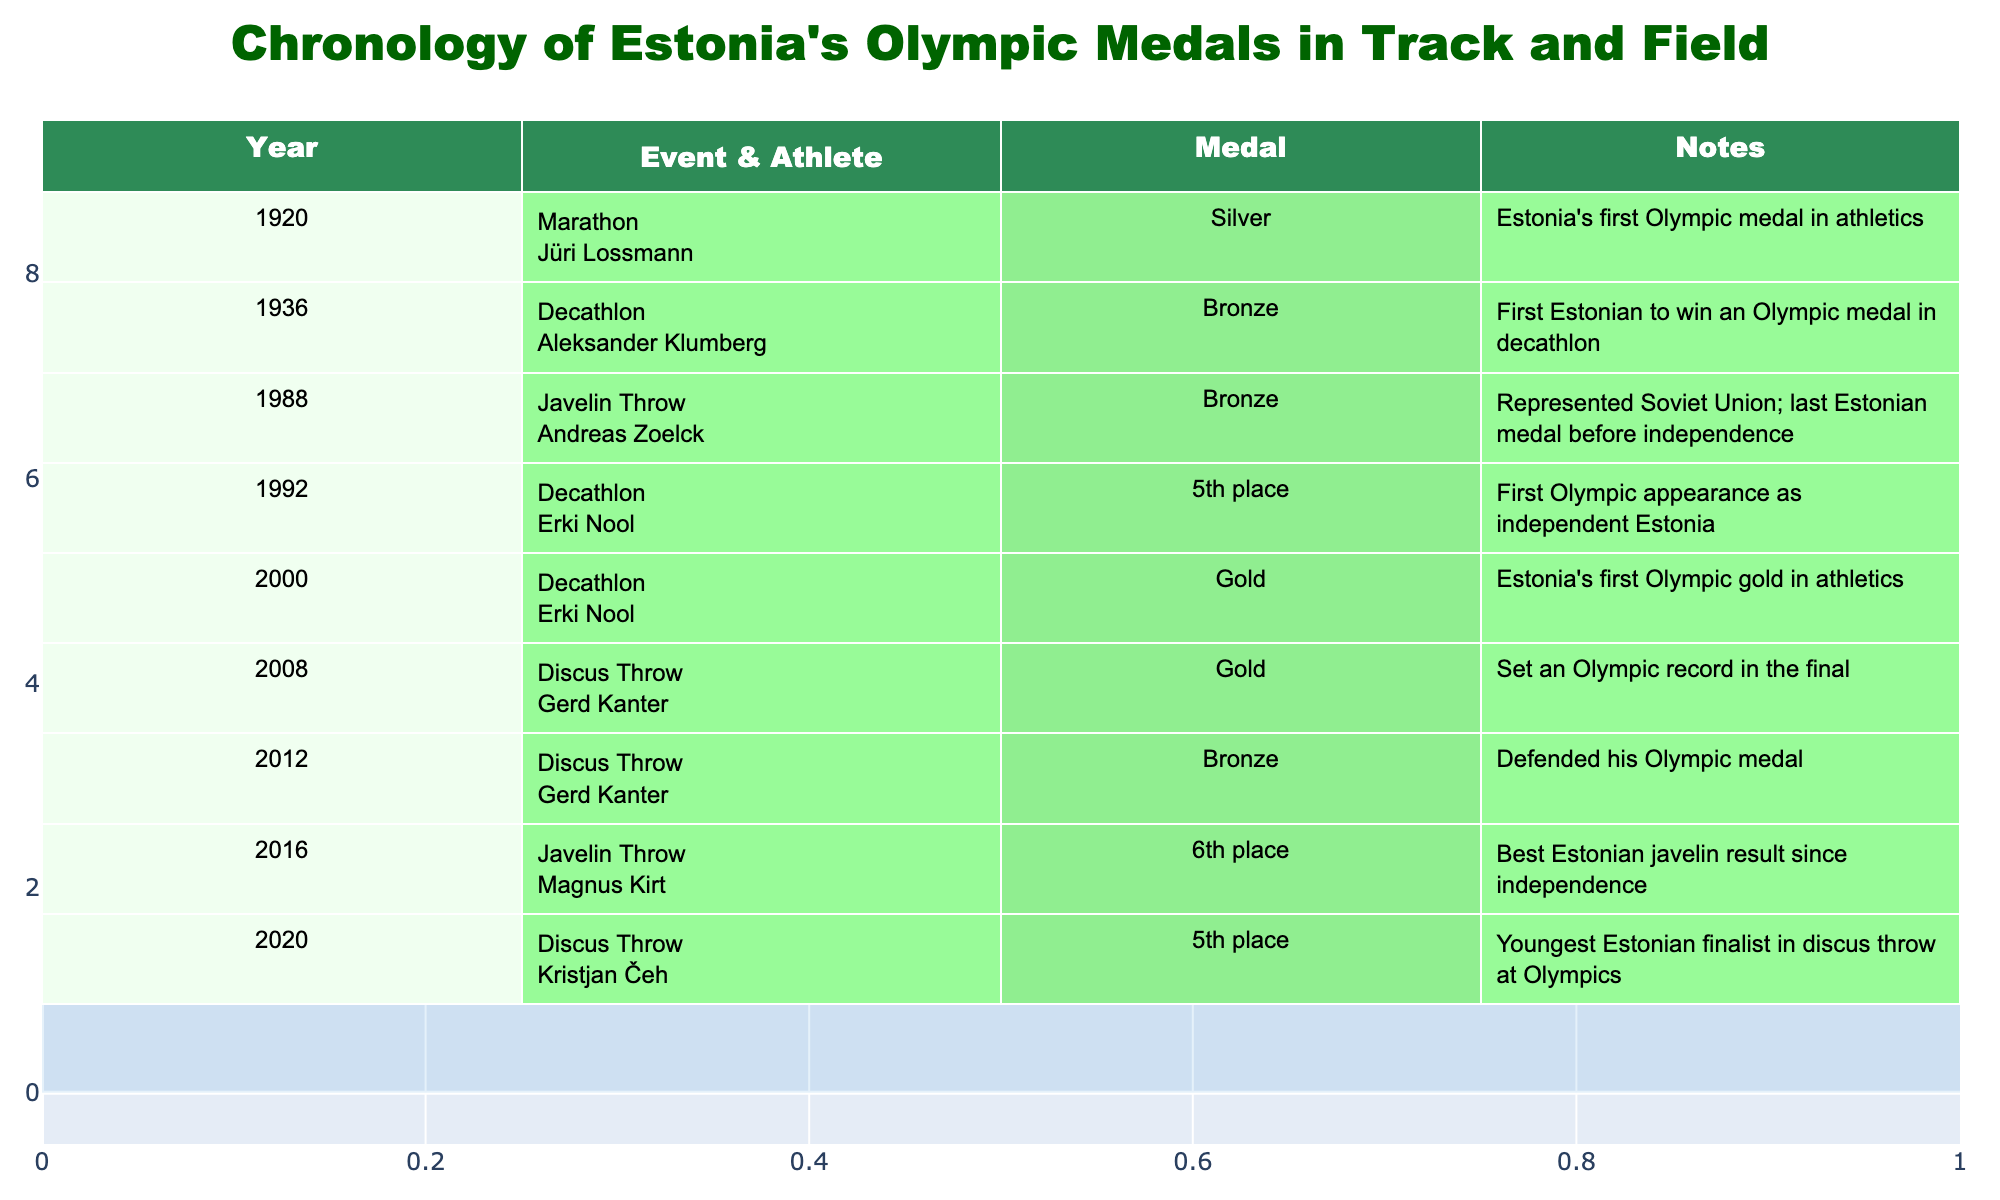What year did Estonia win its first Olympic medal in athletics? The table indicates that the first Olympic medal in athletics was won in the year 1920, when Jüri Lossmann secured a silver in the marathon.
Answer: 1920 How many athletes have won medals for Estonia in Olympic track and field events? By counting the distinct athletes listed in the table—Jüri Lossmann, Aleksander Klumberg, Andreas Zoelck, Erki Nool, Gerd Kanter, Magnus Kirt, and Kristjan Čeh—we find there are 7 unique athletes.
Answer: 7 Which event has the highest number of medals won by an Estonian athlete? The disc throw event has the highest frequency of medals listed with a total of 3 medals: one gold in 2008 and two medals in 2012 (a gold and a bronze).
Answer: Discus Throw What is the difference in medal color between the years 2000 and 2008? In the year 2000, Erki Nool won a gold medal, while in 2008, Gerd Kanter also won a gold medal. The color of the medals is the same, which means there is no difference.
Answer: No difference Did Estonia win any medals in track events during the Olympics according to the table? Referring to the table, there are no medals listed for track events specifically; all listed events are field events or the marathon, which is a distance event.
Answer: No What was the average age of Estonian medalists during the years represented in the table? To compute the average age of medalists, we cannot derive ages directly from the table, but we can deduce that the achievements span several decades, notably from 1920 to 2020. Without explicit ages, a typical range can be assumed for further research. Since it's not calculable from the available data, we'll note the necessity of age data.
Answer: Not calculable How many total medals does Erki Nool have according to the table? The table shows that Erki Nool won a gold medal in 2000 and finished in 5th place in 1992, providing one medal from the tracked years listed.
Answer: 1 Between which two events did Estonia have its last Olympic medal before independence? The last medal won before independence was in 1988, in the javelin throw. The subsequent entries note Erki Nool's 5th place in 1992, marking this as the cutoff.
Answer: Javelin Throw and Decathlon 